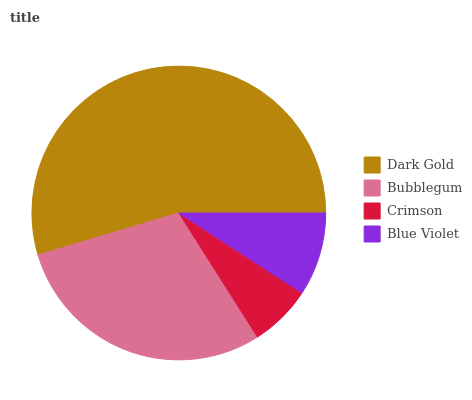Is Crimson the minimum?
Answer yes or no. Yes. Is Dark Gold the maximum?
Answer yes or no. Yes. Is Bubblegum the minimum?
Answer yes or no. No. Is Bubblegum the maximum?
Answer yes or no. No. Is Dark Gold greater than Bubblegum?
Answer yes or no. Yes. Is Bubblegum less than Dark Gold?
Answer yes or no. Yes. Is Bubblegum greater than Dark Gold?
Answer yes or no. No. Is Dark Gold less than Bubblegum?
Answer yes or no. No. Is Bubblegum the high median?
Answer yes or no. Yes. Is Blue Violet the low median?
Answer yes or no. Yes. Is Blue Violet the high median?
Answer yes or no. No. Is Bubblegum the low median?
Answer yes or no. No. 